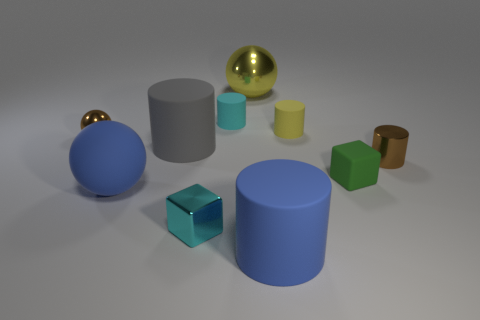There is a tiny cyan object behind the big sphere that is to the left of the tiny cyan object that is behind the tiny brown metallic cylinder; what is it made of?
Make the answer very short. Rubber. How many objects are either big cyan matte balls or small things behind the tiny cyan metallic block?
Provide a succinct answer. 5. What is the tiny brown object to the left of the large yellow thing made of?
Ensure brevity in your answer.  Metal. What is the shape of the yellow object that is the same size as the matte block?
Keep it short and to the point. Cylinder. Are there any green things of the same shape as the cyan metal object?
Make the answer very short. Yes. Do the green block and the large object that is in front of the big blue ball have the same material?
Provide a succinct answer. Yes. What is the material of the tiny brown object that is to the right of the metal ball that is behind the tiny yellow thing?
Ensure brevity in your answer.  Metal. Is the number of matte objects on the right side of the yellow matte cylinder greater than the number of yellow metal cylinders?
Your response must be concise. Yes. Are any big red metal cylinders visible?
Give a very brief answer. No. What is the color of the block that is right of the small yellow thing?
Offer a very short reply. Green. 